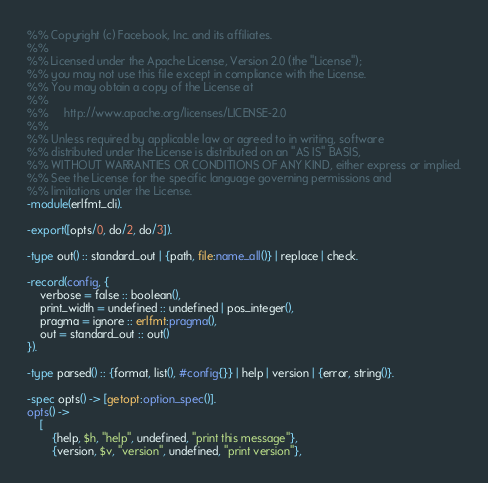Convert code to text. <code><loc_0><loc_0><loc_500><loc_500><_Erlang_>%% Copyright (c) Facebook, Inc. and its affiliates.
%%
%% Licensed under the Apache License, Version 2.0 (the "License");
%% you may not use this file except in compliance with the License.
%% You may obtain a copy of the License at
%%
%%     http://www.apache.org/licenses/LICENSE-2.0
%%
%% Unless required by applicable law or agreed to in writing, software
%% distributed under the License is distributed on an "AS IS" BASIS,
%% WITHOUT WARRANTIES OR CONDITIONS OF ANY KIND, either express or implied.
%% See the License for the specific language governing permissions and
%% limitations under the License.
-module(erlfmt_cli).

-export([opts/0, do/2, do/3]).

-type out() :: standard_out | {path, file:name_all()} | replace | check.

-record(config, {
    verbose = false :: boolean(),
    print_width = undefined :: undefined | pos_integer(),
    pragma = ignore :: erlfmt:pragma(),
    out = standard_out :: out()
}).

-type parsed() :: {format, list(), #config{}} | help | version | {error, string()}.

-spec opts() -> [getopt:option_spec()].
opts() ->
    [
        {help, $h, "help", undefined, "print this message"},
        {version, $v, "version", undefined, "print version"},</code> 